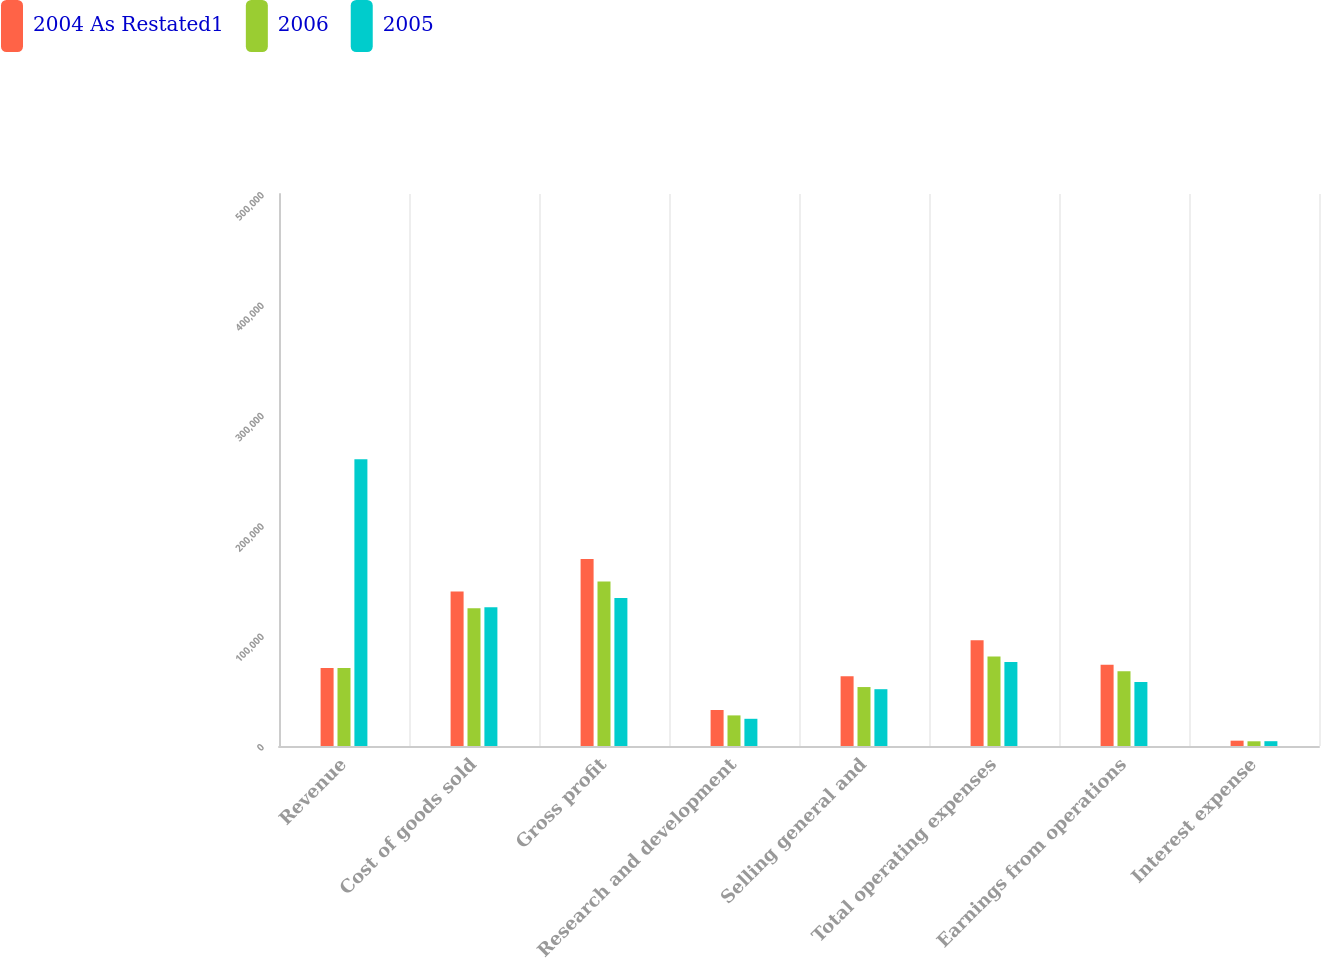Convert chart to OTSL. <chart><loc_0><loc_0><loc_500><loc_500><stacked_bar_chart><ecel><fcel>Revenue<fcel>Cost of goods sold<fcel>Gross profit<fcel>Research and development<fcel>Selling general and<fcel>Total operating expenses<fcel>Earnings from operations<fcel>Interest expense<nl><fcel>2004 As Restated1<fcel>131454<fcel>260087<fcel>314913<fcel>60584<fcel>117374<fcel>177958<fcel>136955<fcel>8956<nl><fcel>2006<fcel>131454<fcel>231867<fcel>276694<fcel>51514<fcel>99227<fcel>150741<fcel>125953<fcel>7922<nl><fcel>2005<fcel>482651<fcel>233492<fcel>249159<fcel>45796<fcel>95605<fcel>141401<fcel>107758<fcel>8092<nl></chart> 